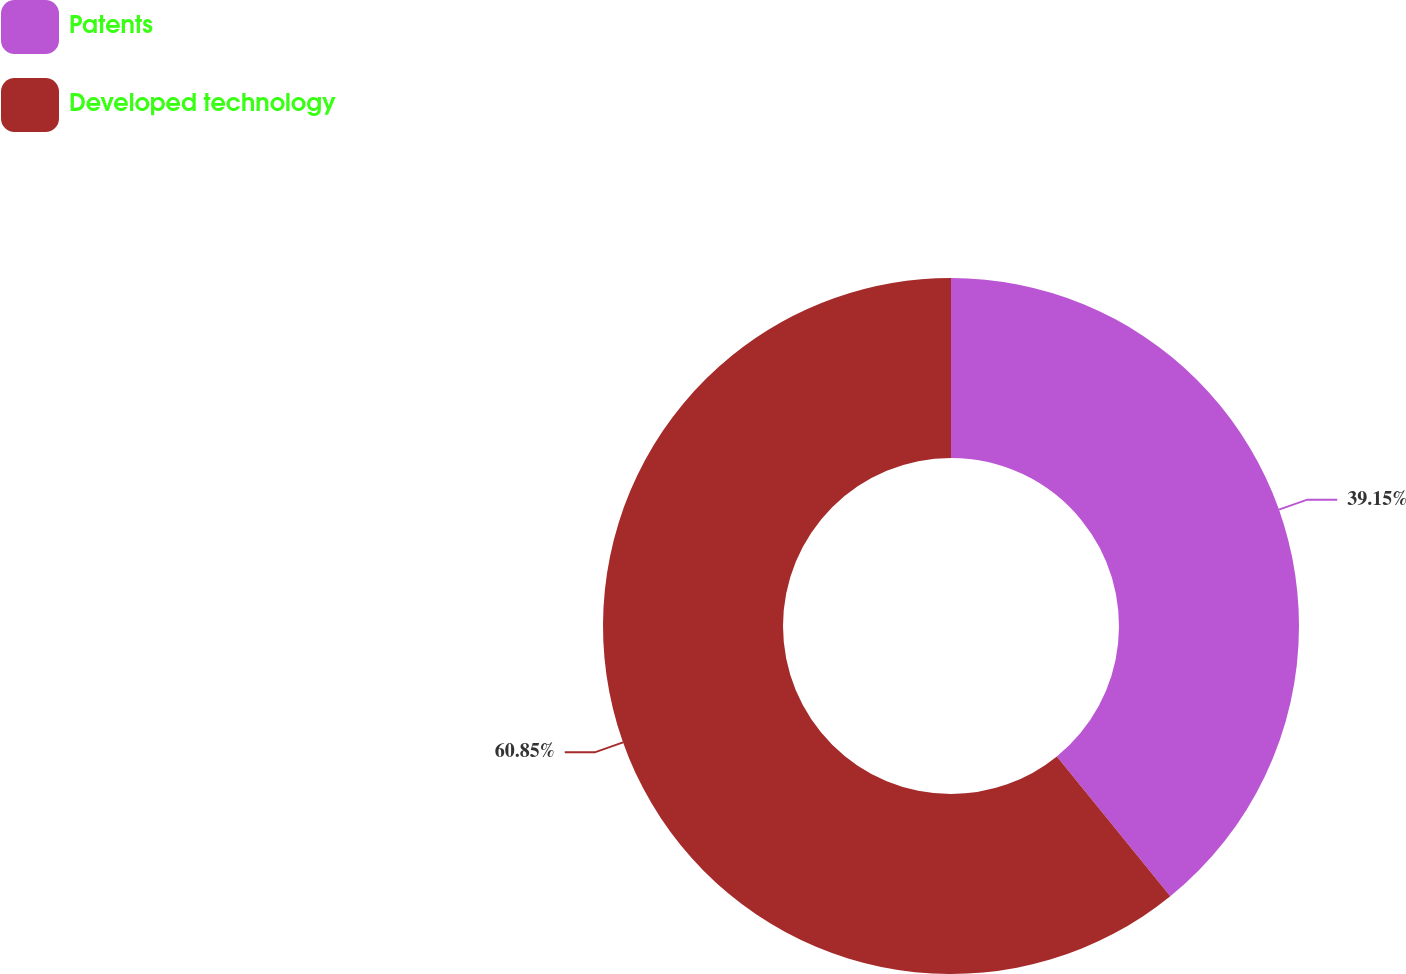<chart> <loc_0><loc_0><loc_500><loc_500><pie_chart><fcel>Patents<fcel>Developed technology<nl><fcel>39.15%<fcel>60.85%<nl></chart> 